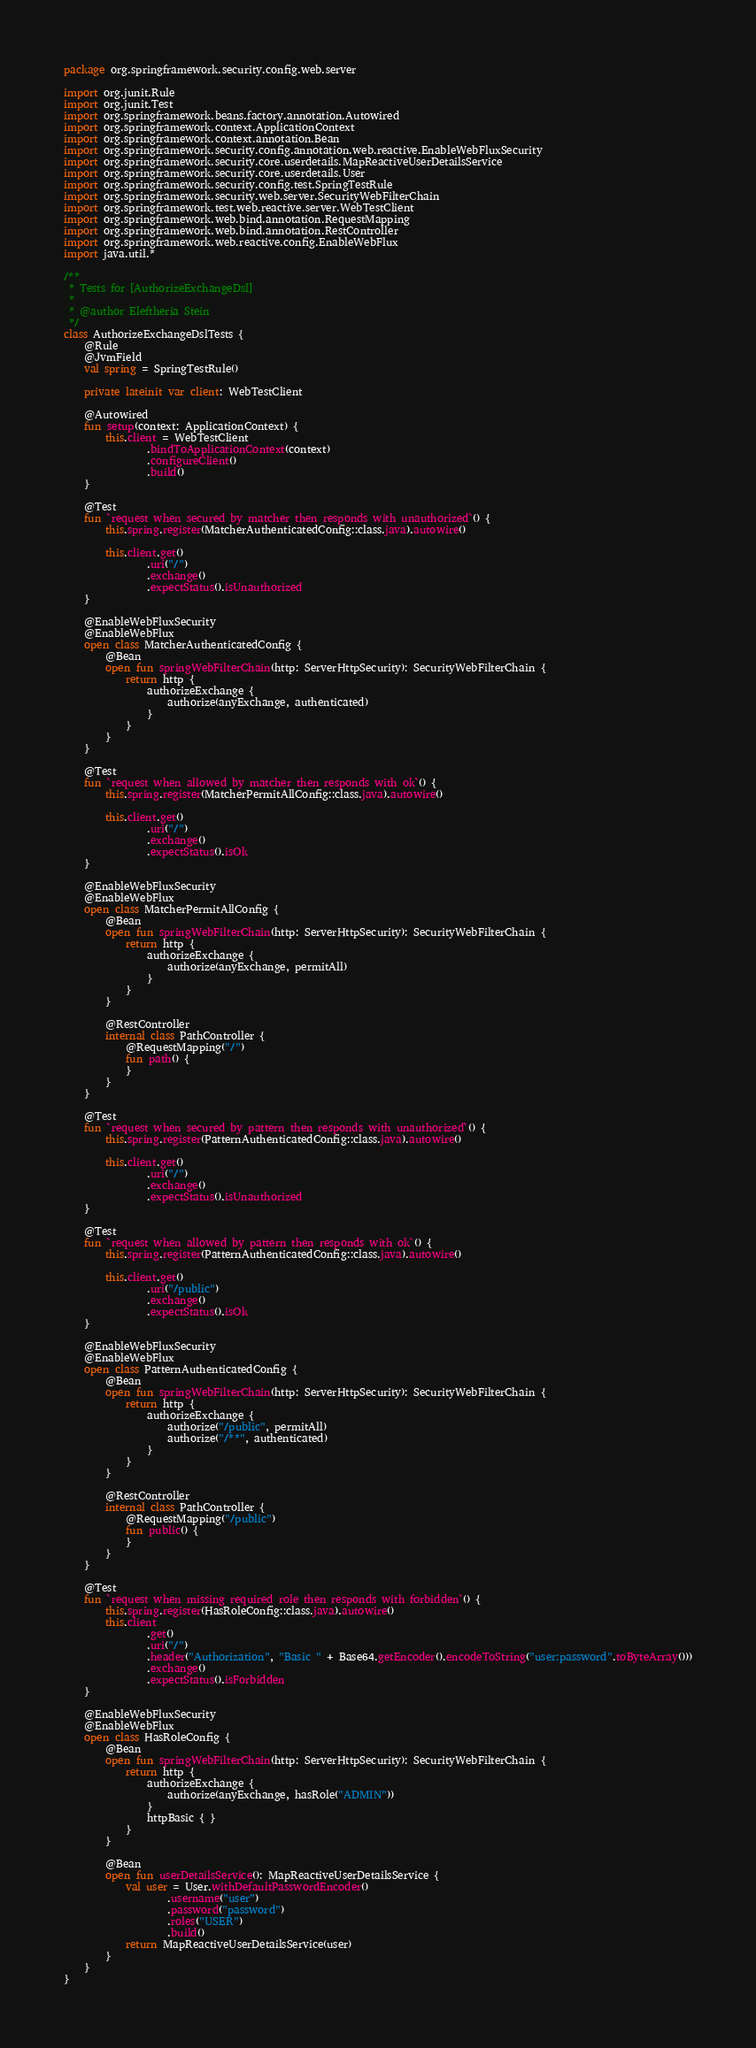<code> <loc_0><loc_0><loc_500><loc_500><_Kotlin_>package org.springframework.security.config.web.server

import org.junit.Rule
import org.junit.Test
import org.springframework.beans.factory.annotation.Autowired
import org.springframework.context.ApplicationContext
import org.springframework.context.annotation.Bean
import org.springframework.security.config.annotation.web.reactive.EnableWebFluxSecurity
import org.springframework.security.core.userdetails.MapReactiveUserDetailsService
import org.springframework.security.core.userdetails.User
import org.springframework.security.config.test.SpringTestRule
import org.springframework.security.web.server.SecurityWebFilterChain
import org.springframework.test.web.reactive.server.WebTestClient
import org.springframework.web.bind.annotation.RequestMapping
import org.springframework.web.bind.annotation.RestController
import org.springframework.web.reactive.config.EnableWebFlux
import java.util.*

/**
 * Tests for [AuthorizeExchangeDsl]
 *
 * @author Eleftheria Stein
 */
class AuthorizeExchangeDslTests {
    @Rule
    @JvmField
    val spring = SpringTestRule()

    private lateinit var client: WebTestClient

    @Autowired
    fun setup(context: ApplicationContext) {
        this.client = WebTestClient
                .bindToApplicationContext(context)
                .configureClient()
                .build()
    }

    @Test
    fun `request when secured by matcher then responds with unauthorized`() {
        this.spring.register(MatcherAuthenticatedConfig::class.java).autowire()

        this.client.get()
                .uri("/")
                .exchange()
                .expectStatus().isUnauthorized
    }

    @EnableWebFluxSecurity
    @EnableWebFlux
    open class MatcherAuthenticatedConfig {
        @Bean
        open fun springWebFilterChain(http: ServerHttpSecurity): SecurityWebFilterChain {
            return http {
                authorizeExchange {
                    authorize(anyExchange, authenticated)
                }
            }
        }
    }

    @Test
    fun `request when allowed by matcher then responds with ok`() {
        this.spring.register(MatcherPermitAllConfig::class.java).autowire()

        this.client.get()
                .uri("/")
                .exchange()
                .expectStatus().isOk
    }

    @EnableWebFluxSecurity
    @EnableWebFlux
    open class MatcherPermitAllConfig {
        @Bean
        open fun springWebFilterChain(http: ServerHttpSecurity): SecurityWebFilterChain {
            return http {
                authorizeExchange {
                    authorize(anyExchange, permitAll)
                }
            }
        }

        @RestController
        internal class PathController {
            @RequestMapping("/")
            fun path() {
            }
        }
    }

    @Test
    fun `request when secured by pattern then responds with unauthorized`() {
        this.spring.register(PatternAuthenticatedConfig::class.java).autowire()

        this.client.get()
                .uri("/")
                .exchange()
                .expectStatus().isUnauthorized
    }

    @Test
    fun `request when allowed by pattern then responds with ok`() {
        this.spring.register(PatternAuthenticatedConfig::class.java).autowire()

        this.client.get()
                .uri("/public")
                .exchange()
                .expectStatus().isOk
    }

    @EnableWebFluxSecurity
    @EnableWebFlux
    open class PatternAuthenticatedConfig {
        @Bean
        open fun springWebFilterChain(http: ServerHttpSecurity): SecurityWebFilterChain {
            return http {
                authorizeExchange {
                    authorize("/public", permitAll)
                    authorize("/**", authenticated)
                }
            }
        }

        @RestController
        internal class PathController {
            @RequestMapping("/public")
            fun public() {
            }
        }
    }

    @Test
    fun `request when missing required role then responds with forbidden`() {
        this.spring.register(HasRoleConfig::class.java).autowire()
        this.client
                .get()
                .uri("/")
                .header("Authorization", "Basic " + Base64.getEncoder().encodeToString("user:password".toByteArray()))
                .exchange()
                .expectStatus().isForbidden
    }

    @EnableWebFluxSecurity
    @EnableWebFlux
    open class HasRoleConfig {
        @Bean
        open fun springWebFilterChain(http: ServerHttpSecurity): SecurityWebFilterChain {
            return http {
                authorizeExchange {
                    authorize(anyExchange, hasRole("ADMIN"))
                }
                httpBasic { }
            }
        }

        @Bean
        open fun userDetailsService(): MapReactiveUserDetailsService {
            val user = User.withDefaultPasswordEncoder()
                    .username("user")
                    .password("password")
                    .roles("USER")
                    .build()
            return MapReactiveUserDetailsService(user)
        }
    }
}
</code> 